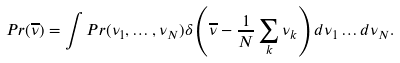Convert formula to latex. <formula><loc_0><loc_0><loc_500><loc_500>P r ( \overline { \nu } ) = \int P r ( \nu _ { 1 } , \dots , \nu _ { N } ) \delta \left ( \overline { \nu } - \frac { 1 } { N } \sum _ { k } \nu _ { k } \right ) d \nu _ { 1 } \dots d \nu _ { N } .</formula> 